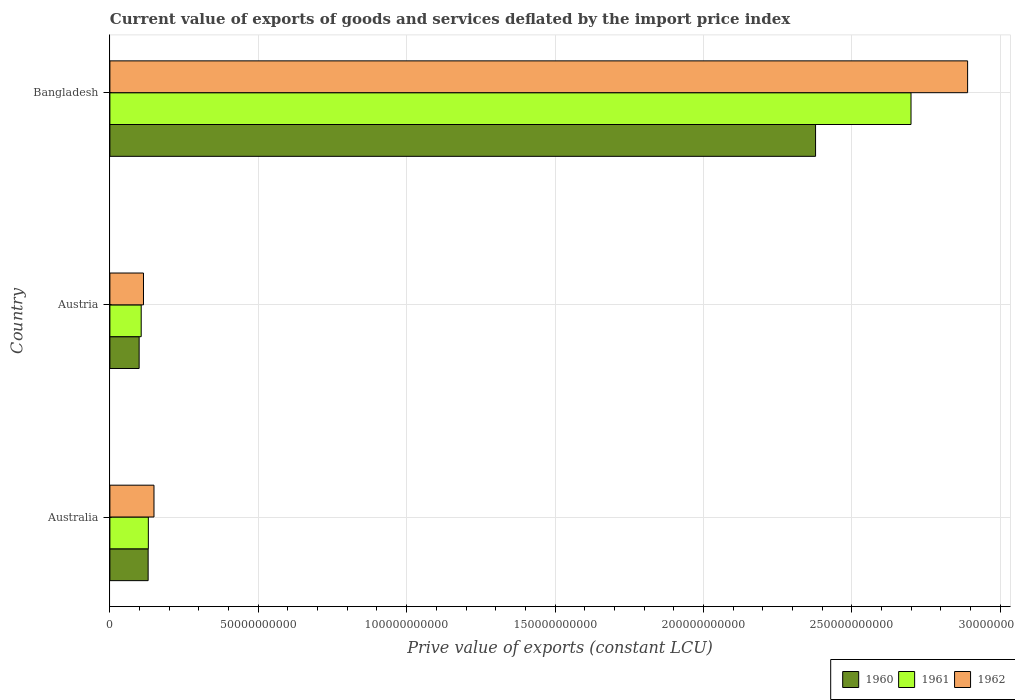Are the number of bars on each tick of the Y-axis equal?
Keep it short and to the point. Yes. How many bars are there on the 1st tick from the bottom?
Provide a short and direct response. 3. What is the prive value of exports in 1962 in Bangladesh?
Offer a very short reply. 2.89e+11. Across all countries, what is the maximum prive value of exports in 1962?
Your answer should be compact. 2.89e+11. Across all countries, what is the minimum prive value of exports in 1962?
Your response must be concise. 1.13e+1. In which country was the prive value of exports in 1962 maximum?
Your response must be concise. Bangladesh. What is the total prive value of exports in 1960 in the graph?
Give a very brief answer. 2.61e+11. What is the difference between the prive value of exports in 1961 in Austria and that in Bangladesh?
Ensure brevity in your answer.  -2.59e+11. What is the difference between the prive value of exports in 1962 in Bangladesh and the prive value of exports in 1961 in Austria?
Your answer should be very brief. 2.78e+11. What is the average prive value of exports in 1960 per country?
Provide a succinct answer. 8.68e+1. What is the difference between the prive value of exports in 1961 and prive value of exports in 1960 in Bangladesh?
Ensure brevity in your answer.  3.22e+1. What is the ratio of the prive value of exports in 1961 in Austria to that in Bangladesh?
Give a very brief answer. 0.04. Is the prive value of exports in 1960 in Austria less than that in Bangladesh?
Provide a short and direct response. Yes. Is the difference between the prive value of exports in 1961 in Austria and Bangladesh greater than the difference between the prive value of exports in 1960 in Austria and Bangladesh?
Your answer should be very brief. No. What is the difference between the highest and the second highest prive value of exports in 1962?
Your response must be concise. 2.74e+11. What is the difference between the highest and the lowest prive value of exports in 1962?
Your answer should be compact. 2.78e+11. What does the 3rd bar from the bottom in Australia represents?
Offer a terse response. 1962. Is it the case that in every country, the sum of the prive value of exports in 1961 and prive value of exports in 1962 is greater than the prive value of exports in 1960?
Provide a succinct answer. Yes. How many bars are there?
Your answer should be very brief. 9. Are all the bars in the graph horizontal?
Give a very brief answer. Yes. How many countries are there in the graph?
Your answer should be very brief. 3. Does the graph contain any zero values?
Offer a very short reply. No. Does the graph contain grids?
Make the answer very short. Yes. Where does the legend appear in the graph?
Offer a terse response. Bottom right. How many legend labels are there?
Make the answer very short. 3. How are the legend labels stacked?
Offer a terse response. Horizontal. What is the title of the graph?
Provide a succinct answer. Current value of exports of goods and services deflated by the import price index. Does "2003" appear as one of the legend labels in the graph?
Ensure brevity in your answer.  No. What is the label or title of the X-axis?
Your answer should be very brief. Prive value of exports (constant LCU). What is the Prive value of exports (constant LCU) in 1960 in Australia?
Make the answer very short. 1.29e+1. What is the Prive value of exports (constant LCU) in 1961 in Australia?
Your answer should be compact. 1.30e+1. What is the Prive value of exports (constant LCU) of 1962 in Australia?
Your answer should be compact. 1.49e+1. What is the Prive value of exports (constant LCU) in 1960 in Austria?
Offer a very short reply. 9.86e+09. What is the Prive value of exports (constant LCU) of 1961 in Austria?
Your response must be concise. 1.06e+1. What is the Prive value of exports (constant LCU) of 1962 in Austria?
Your response must be concise. 1.13e+1. What is the Prive value of exports (constant LCU) in 1960 in Bangladesh?
Provide a short and direct response. 2.38e+11. What is the Prive value of exports (constant LCU) of 1961 in Bangladesh?
Keep it short and to the point. 2.70e+11. What is the Prive value of exports (constant LCU) of 1962 in Bangladesh?
Offer a very short reply. 2.89e+11. Across all countries, what is the maximum Prive value of exports (constant LCU) of 1960?
Ensure brevity in your answer.  2.38e+11. Across all countries, what is the maximum Prive value of exports (constant LCU) in 1961?
Offer a terse response. 2.70e+11. Across all countries, what is the maximum Prive value of exports (constant LCU) of 1962?
Provide a succinct answer. 2.89e+11. Across all countries, what is the minimum Prive value of exports (constant LCU) in 1960?
Ensure brevity in your answer.  9.86e+09. Across all countries, what is the minimum Prive value of exports (constant LCU) in 1961?
Offer a very short reply. 1.06e+1. Across all countries, what is the minimum Prive value of exports (constant LCU) in 1962?
Make the answer very short. 1.13e+1. What is the total Prive value of exports (constant LCU) of 1960 in the graph?
Your answer should be very brief. 2.61e+11. What is the total Prive value of exports (constant LCU) in 1961 in the graph?
Your answer should be compact. 2.93e+11. What is the total Prive value of exports (constant LCU) in 1962 in the graph?
Make the answer very short. 3.15e+11. What is the difference between the Prive value of exports (constant LCU) in 1960 in Australia and that in Austria?
Your answer should be compact. 3.04e+09. What is the difference between the Prive value of exports (constant LCU) in 1961 in Australia and that in Austria?
Provide a succinct answer. 2.41e+09. What is the difference between the Prive value of exports (constant LCU) of 1962 in Australia and that in Austria?
Provide a succinct answer. 3.54e+09. What is the difference between the Prive value of exports (constant LCU) of 1960 in Australia and that in Bangladesh?
Make the answer very short. -2.25e+11. What is the difference between the Prive value of exports (constant LCU) of 1961 in Australia and that in Bangladesh?
Keep it short and to the point. -2.57e+11. What is the difference between the Prive value of exports (constant LCU) in 1962 in Australia and that in Bangladesh?
Offer a very short reply. -2.74e+11. What is the difference between the Prive value of exports (constant LCU) of 1960 in Austria and that in Bangladesh?
Offer a very short reply. -2.28e+11. What is the difference between the Prive value of exports (constant LCU) of 1961 in Austria and that in Bangladesh?
Provide a short and direct response. -2.59e+11. What is the difference between the Prive value of exports (constant LCU) in 1962 in Austria and that in Bangladesh?
Your answer should be very brief. -2.78e+11. What is the difference between the Prive value of exports (constant LCU) of 1960 in Australia and the Prive value of exports (constant LCU) of 1961 in Austria?
Provide a succinct answer. 2.34e+09. What is the difference between the Prive value of exports (constant LCU) of 1960 in Australia and the Prive value of exports (constant LCU) of 1962 in Austria?
Your answer should be very brief. 1.57e+09. What is the difference between the Prive value of exports (constant LCU) of 1961 in Australia and the Prive value of exports (constant LCU) of 1962 in Austria?
Ensure brevity in your answer.  1.64e+09. What is the difference between the Prive value of exports (constant LCU) of 1960 in Australia and the Prive value of exports (constant LCU) of 1961 in Bangladesh?
Give a very brief answer. -2.57e+11. What is the difference between the Prive value of exports (constant LCU) of 1960 in Australia and the Prive value of exports (constant LCU) of 1962 in Bangladesh?
Your answer should be compact. -2.76e+11. What is the difference between the Prive value of exports (constant LCU) of 1961 in Australia and the Prive value of exports (constant LCU) of 1962 in Bangladesh?
Ensure brevity in your answer.  -2.76e+11. What is the difference between the Prive value of exports (constant LCU) in 1960 in Austria and the Prive value of exports (constant LCU) in 1961 in Bangladesh?
Keep it short and to the point. -2.60e+11. What is the difference between the Prive value of exports (constant LCU) of 1960 in Austria and the Prive value of exports (constant LCU) of 1962 in Bangladesh?
Offer a terse response. -2.79e+11. What is the difference between the Prive value of exports (constant LCU) in 1961 in Austria and the Prive value of exports (constant LCU) in 1962 in Bangladesh?
Offer a very short reply. -2.78e+11. What is the average Prive value of exports (constant LCU) in 1960 per country?
Offer a very short reply. 8.68e+1. What is the average Prive value of exports (constant LCU) in 1961 per country?
Offer a terse response. 9.78e+1. What is the average Prive value of exports (constant LCU) in 1962 per country?
Offer a very short reply. 1.05e+11. What is the difference between the Prive value of exports (constant LCU) of 1960 and Prive value of exports (constant LCU) of 1961 in Australia?
Your answer should be compact. -6.58e+07. What is the difference between the Prive value of exports (constant LCU) in 1960 and Prive value of exports (constant LCU) in 1962 in Australia?
Give a very brief answer. -1.96e+09. What is the difference between the Prive value of exports (constant LCU) in 1961 and Prive value of exports (constant LCU) in 1962 in Australia?
Offer a terse response. -1.90e+09. What is the difference between the Prive value of exports (constant LCU) in 1960 and Prive value of exports (constant LCU) in 1961 in Austria?
Provide a succinct answer. -6.95e+08. What is the difference between the Prive value of exports (constant LCU) in 1960 and Prive value of exports (constant LCU) in 1962 in Austria?
Offer a very short reply. -1.46e+09. What is the difference between the Prive value of exports (constant LCU) of 1961 and Prive value of exports (constant LCU) of 1962 in Austria?
Provide a short and direct response. -7.67e+08. What is the difference between the Prive value of exports (constant LCU) of 1960 and Prive value of exports (constant LCU) of 1961 in Bangladesh?
Provide a short and direct response. -3.22e+1. What is the difference between the Prive value of exports (constant LCU) of 1960 and Prive value of exports (constant LCU) of 1962 in Bangladesh?
Give a very brief answer. -5.12e+1. What is the difference between the Prive value of exports (constant LCU) of 1961 and Prive value of exports (constant LCU) of 1962 in Bangladesh?
Make the answer very short. -1.91e+1. What is the ratio of the Prive value of exports (constant LCU) of 1960 in Australia to that in Austria?
Provide a short and direct response. 1.31. What is the ratio of the Prive value of exports (constant LCU) in 1961 in Australia to that in Austria?
Offer a terse response. 1.23. What is the ratio of the Prive value of exports (constant LCU) in 1962 in Australia to that in Austria?
Your answer should be compact. 1.31. What is the ratio of the Prive value of exports (constant LCU) in 1960 in Australia to that in Bangladesh?
Offer a terse response. 0.05. What is the ratio of the Prive value of exports (constant LCU) of 1961 in Australia to that in Bangladesh?
Give a very brief answer. 0.05. What is the ratio of the Prive value of exports (constant LCU) of 1962 in Australia to that in Bangladesh?
Your answer should be compact. 0.05. What is the ratio of the Prive value of exports (constant LCU) of 1960 in Austria to that in Bangladesh?
Make the answer very short. 0.04. What is the ratio of the Prive value of exports (constant LCU) of 1961 in Austria to that in Bangladesh?
Your answer should be compact. 0.04. What is the ratio of the Prive value of exports (constant LCU) in 1962 in Austria to that in Bangladesh?
Provide a succinct answer. 0.04. What is the difference between the highest and the second highest Prive value of exports (constant LCU) of 1960?
Ensure brevity in your answer.  2.25e+11. What is the difference between the highest and the second highest Prive value of exports (constant LCU) in 1961?
Your answer should be compact. 2.57e+11. What is the difference between the highest and the second highest Prive value of exports (constant LCU) of 1962?
Your answer should be compact. 2.74e+11. What is the difference between the highest and the lowest Prive value of exports (constant LCU) in 1960?
Make the answer very short. 2.28e+11. What is the difference between the highest and the lowest Prive value of exports (constant LCU) of 1961?
Your answer should be compact. 2.59e+11. What is the difference between the highest and the lowest Prive value of exports (constant LCU) in 1962?
Your answer should be compact. 2.78e+11. 